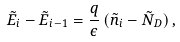Convert formula to latex. <formula><loc_0><loc_0><loc_500><loc_500>\tilde { E } _ { i } - \tilde { E } _ { i - 1 } = \frac { q } { \epsilon } \, ( \tilde { n } _ { i } - \tilde { N } _ { D } ) \, ,</formula> 